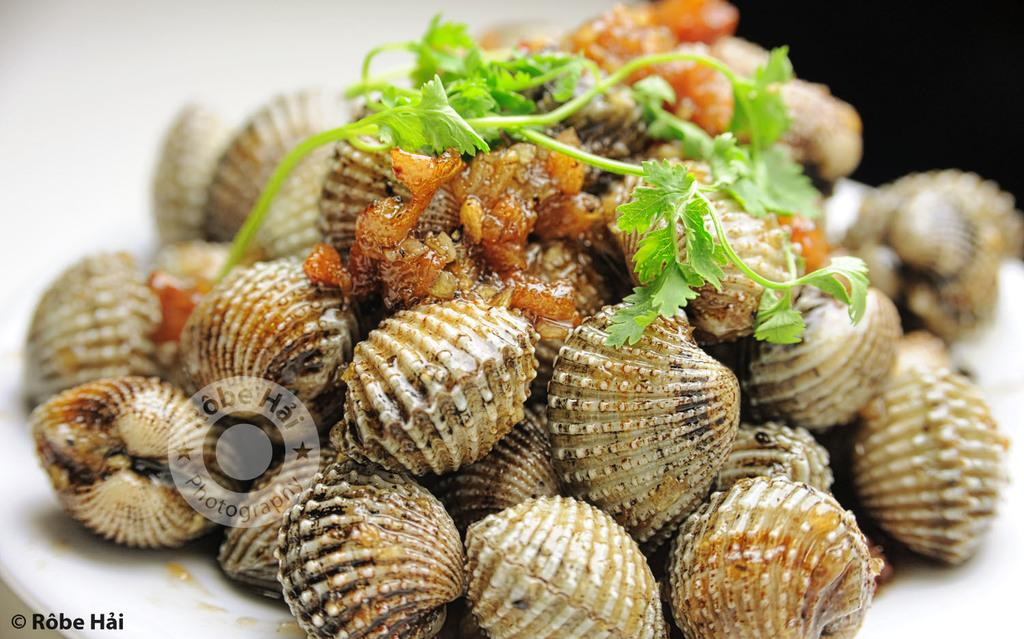What types of food items can be seen in the image? The image contains food items, but the specific types cannot be determined from the provided facts. What herb is present in the image? Coriander leaves are present in the image. How many servants are visible in the image? There are no servants present in the image. What type of bird's wing can be seen in the image? There is no bird or wing visible in the image. 